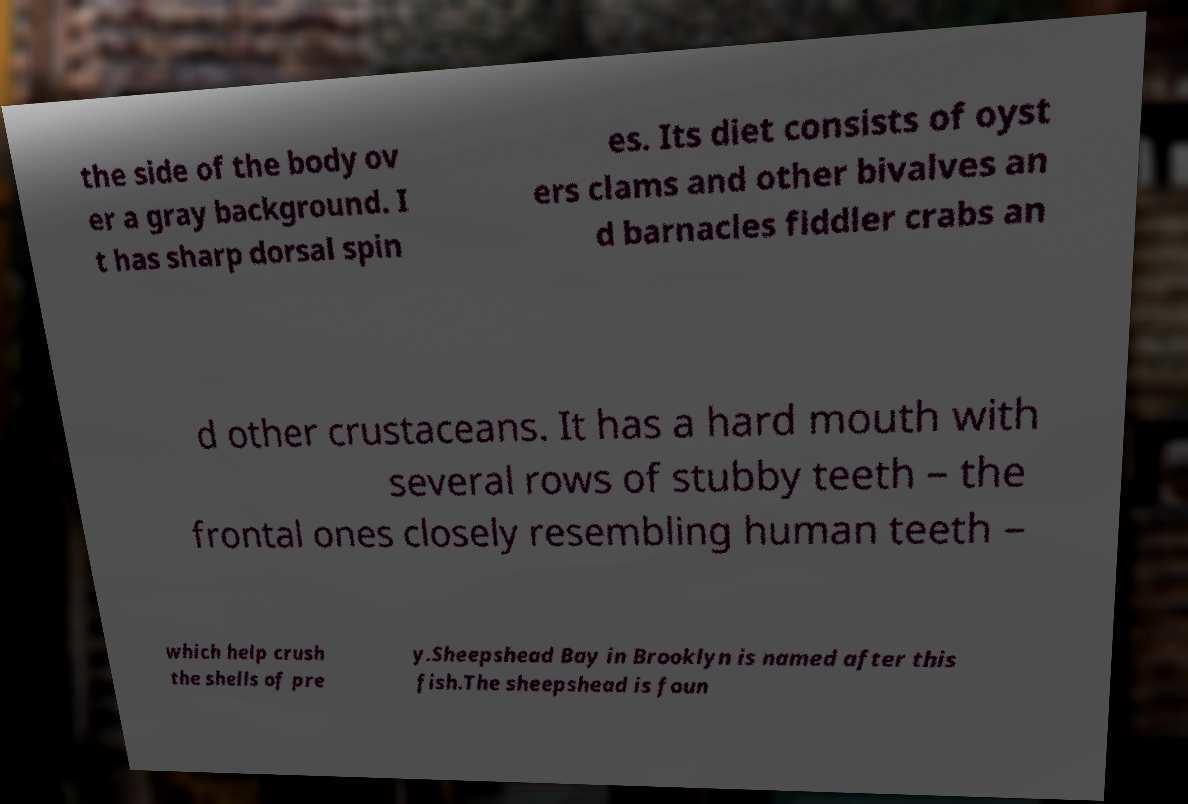What messages or text are displayed in this image? I need them in a readable, typed format. the side of the body ov er a gray background. I t has sharp dorsal spin es. Its diet consists of oyst ers clams and other bivalves an d barnacles fiddler crabs an d other crustaceans. It has a hard mouth with several rows of stubby teeth – the frontal ones closely resembling human teeth – which help crush the shells of pre y.Sheepshead Bay in Brooklyn is named after this fish.The sheepshead is foun 